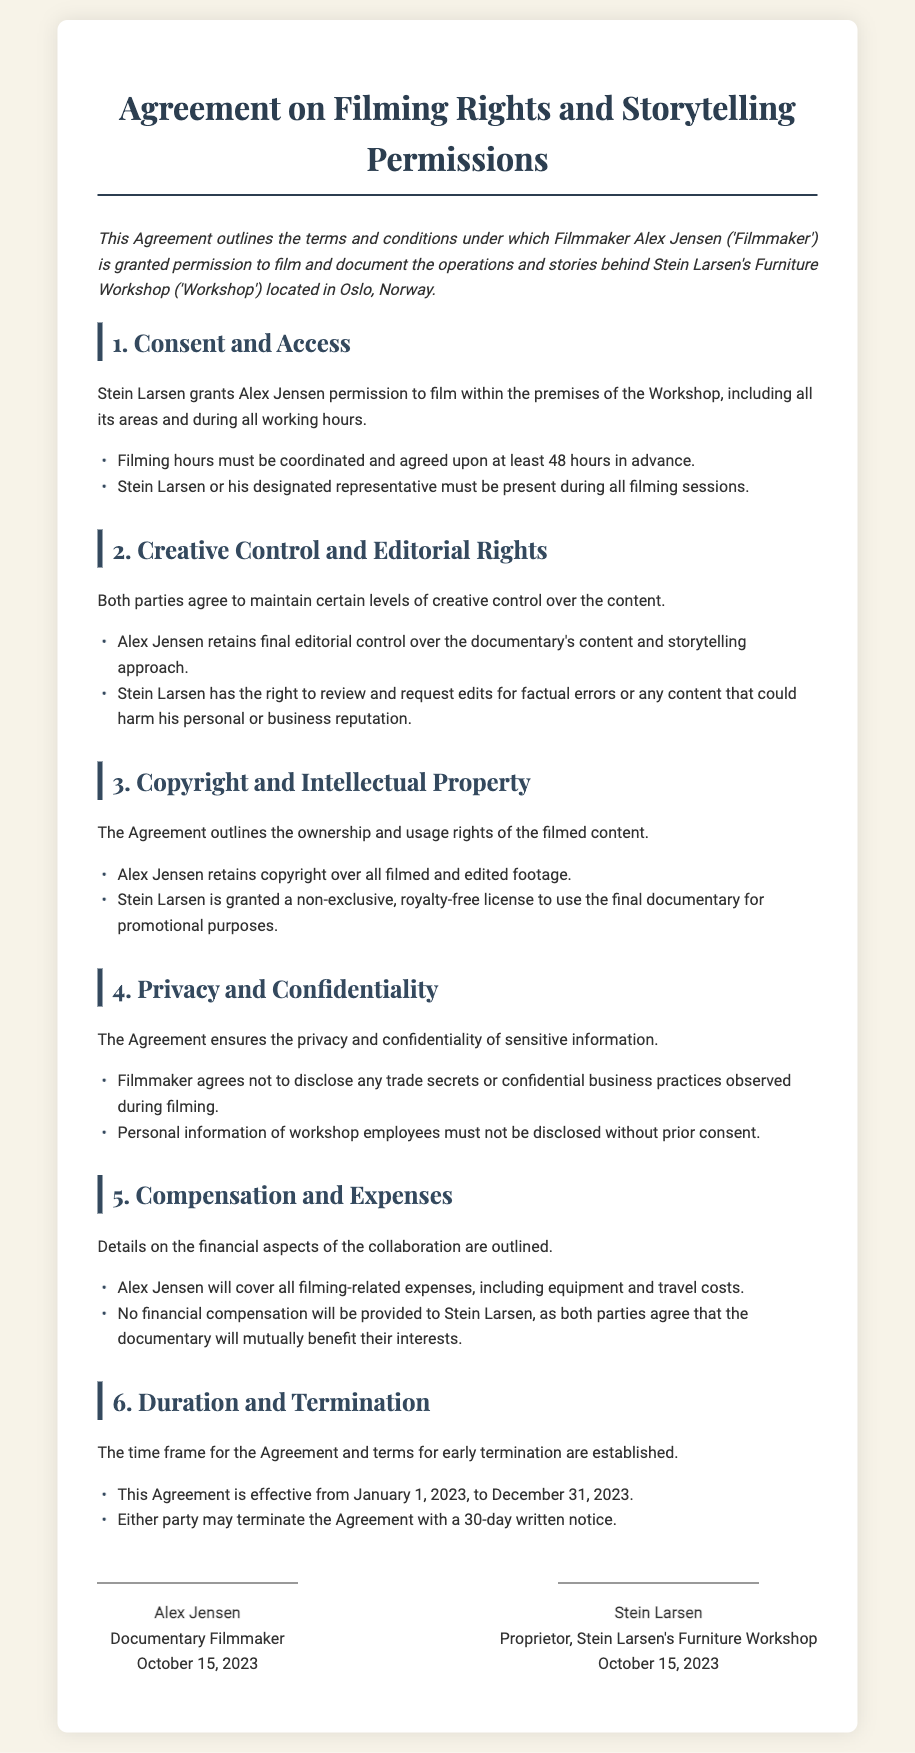What is the name of the Filmmaker? The document states the Filmmaker's name is Alex Jensen.
Answer: Alex Jensen Who is the Proprietor of the Workshop? The document specifies that Stein Larsen is the Proprietor of the Workshop.
Answer: Stein Larsen When does the Agreement become effective? The effective date of the Agreement is mentioned as January 1, 2023.
Answer: January 1, 2023 How long is the duration of the Agreement? The Agreement is effective for one year, ending on December 31, 2023.
Answer: One year What must be done at least 48 hours in advance? The document states that filming hours must be coordinated and agreed upon at least 48 hours in advance.
Answer: Filming hours coordination Who retains final editorial control over the documentary? According to the document, Alex Jensen retains final editorial control over the documentary's content.
Answer: Alex Jensen What type of license is granted to Stein Larsen? The Agreement grants Stein Larsen a non-exclusive, royalty-free license to use the final documentary for promotional purposes.
Answer: Non-exclusive, royalty-free license What is required for early termination of the Agreement? The document requires a 30-day written notice for either party to terminate the Agreement early.
Answer: 30-day written notice 